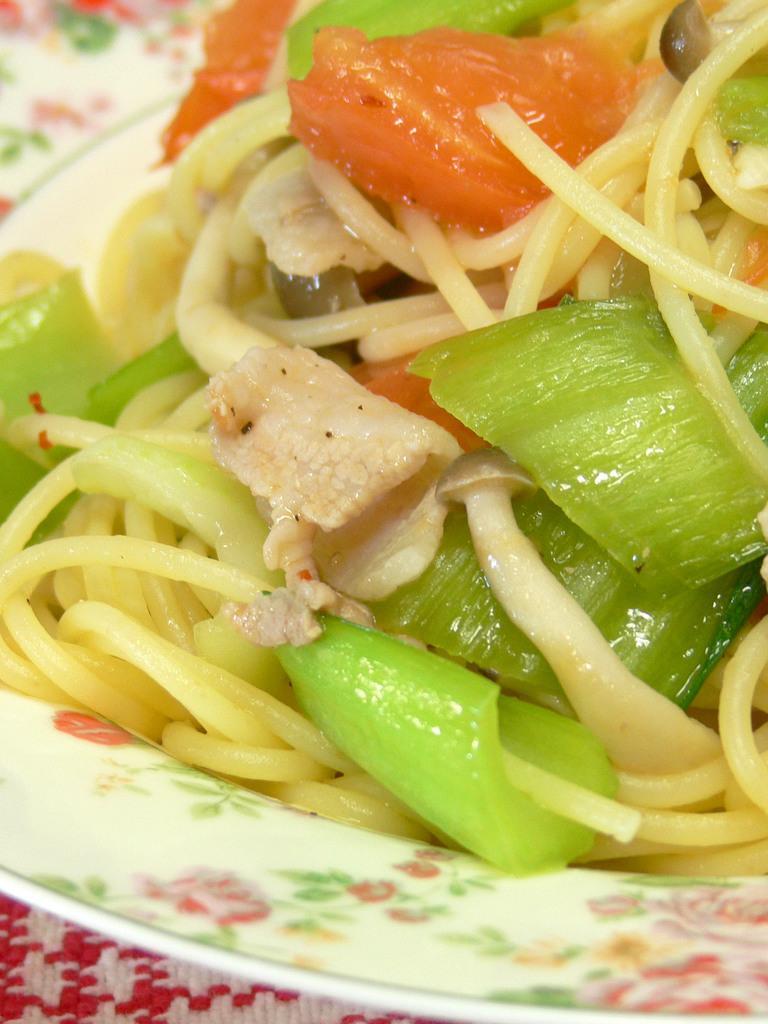Could you give a brief overview of what you see in this image? In the picture I can see a food item on plate with different vegetables. 